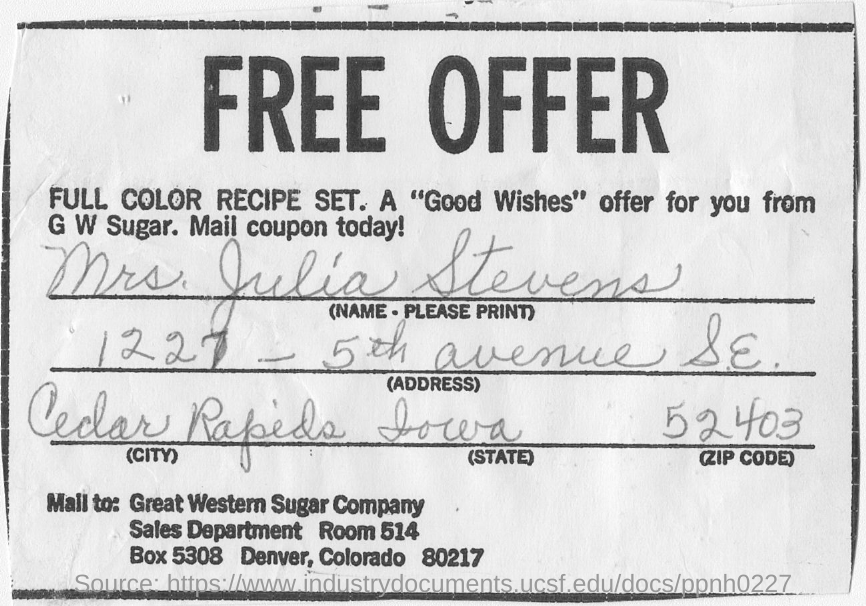What is the head line?
Your response must be concise. FREE OFFER. What is company name mentioned in this coupon?
Offer a very short reply. GREAT WESTERN SUGAR COMPANY. What is the name written in this Coupon?
Your response must be concise. MRS. JULIA STEVENS. 